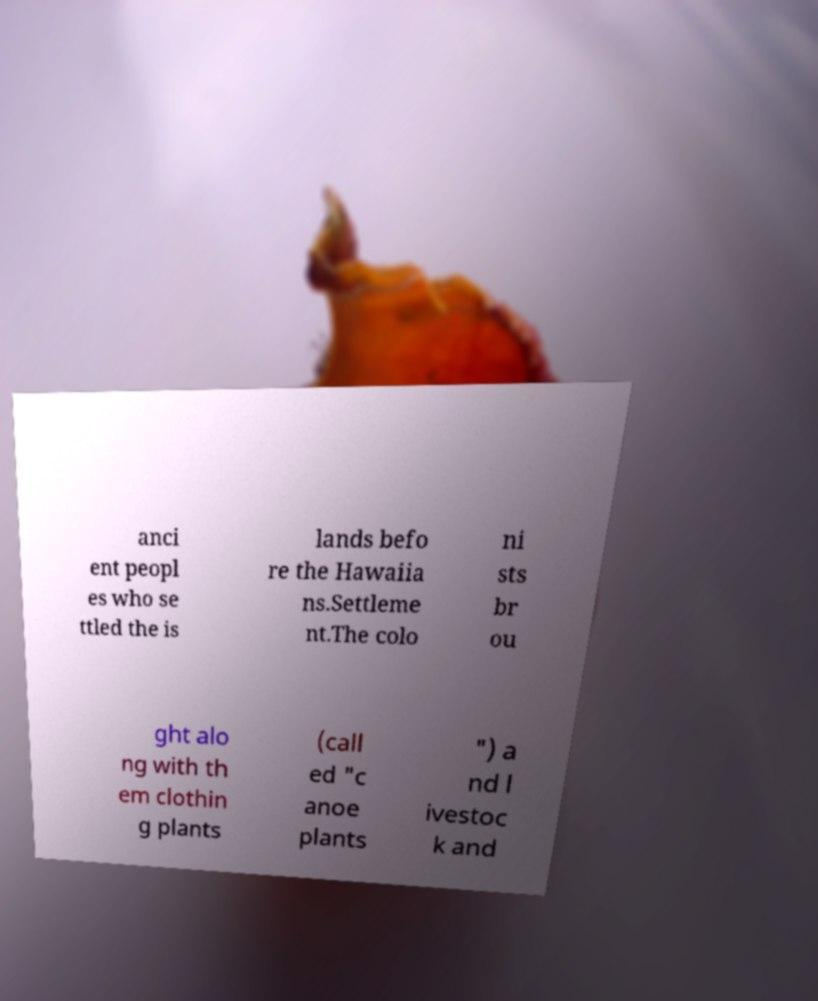Please read and relay the text visible in this image. What does it say? anci ent peopl es who se ttled the is lands befo re the Hawaiia ns.Settleme nt.The colo ni sts br ou ght alo ng with th em clothin g plants (call ed "c anoe plants ") a nd l ivestoc k and 